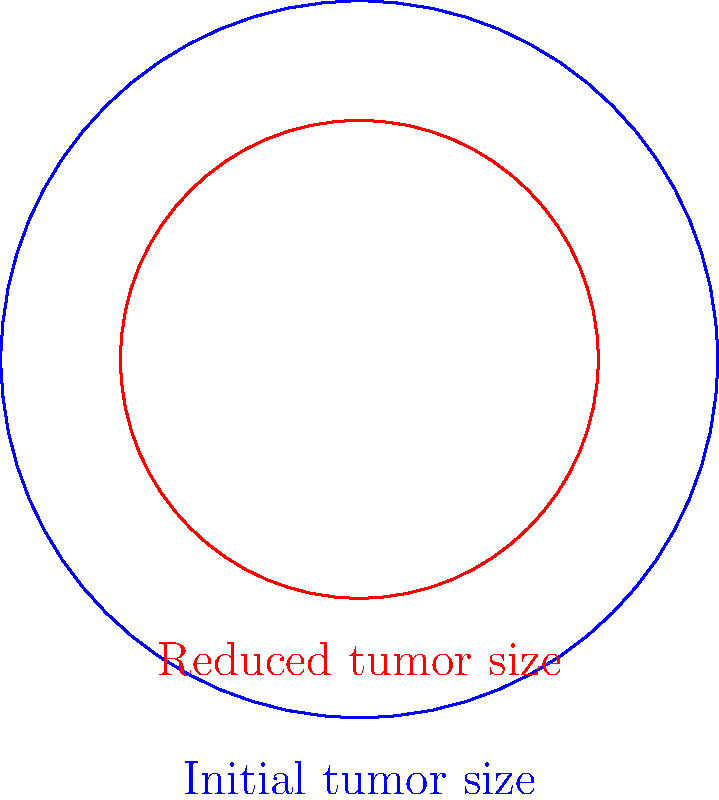Dr. Gaynor's innovative treatment reduced a patient's tumor size. The initial tumor had a radius of 3 cm, represented by the blue circle. After treatment, the tumor's radius decreased to 2 cm, shown by the red circle. What percentage of the original tumor area was eliminated by the treatment? To solve this problem, we'll follow these steps:

1) First, calculate the initial tumor area:
   $A_1 = \pi r_1^2 = \pi (3\text{ cm})^2 = 9\pi \text{ cm}^2$

2) Then, calculate the reduced tumor area:
   $A_2 = \pi r_2^2 = \pi (2\text{ cm})^2 = 4\pi \text{ cm}^2$

3) Find the difference in areas:
   $\Delta A = A_1 - A_2 = 9\pi \text{ cm}^2 - 4\pi \text{ cm}^2 = 5\pi \text{ cm}^2$

4) Calculate the percentage of area eliminated:
   $\text{Percentage eliminated} = \frac{\Delta A}{A_1} \times 100\%$
   $= \frac{5\pi \text{ cm}^2}{9\pi \text{ cm}^2} \times 100\%$
   $= \frac{5}{9} \times 100\% \approx 55.56\%$

Therefore, approximately 55.56% of the original tumor area was eliminated by the treatment.
Answer: 55.56% 